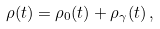<formula> <loc_0><loc_0><loc_500><loc_500>\rho ( t ) = \rho _ { 0 } ( t ) + \rho _ { \gamma } ( t ) \, ,</formula> 